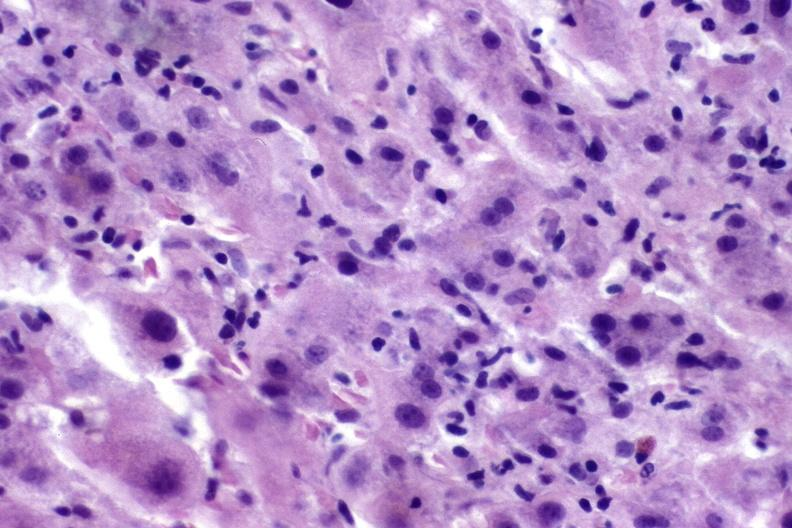s liver present?
Answer the question using a single word or phrase. Yes 